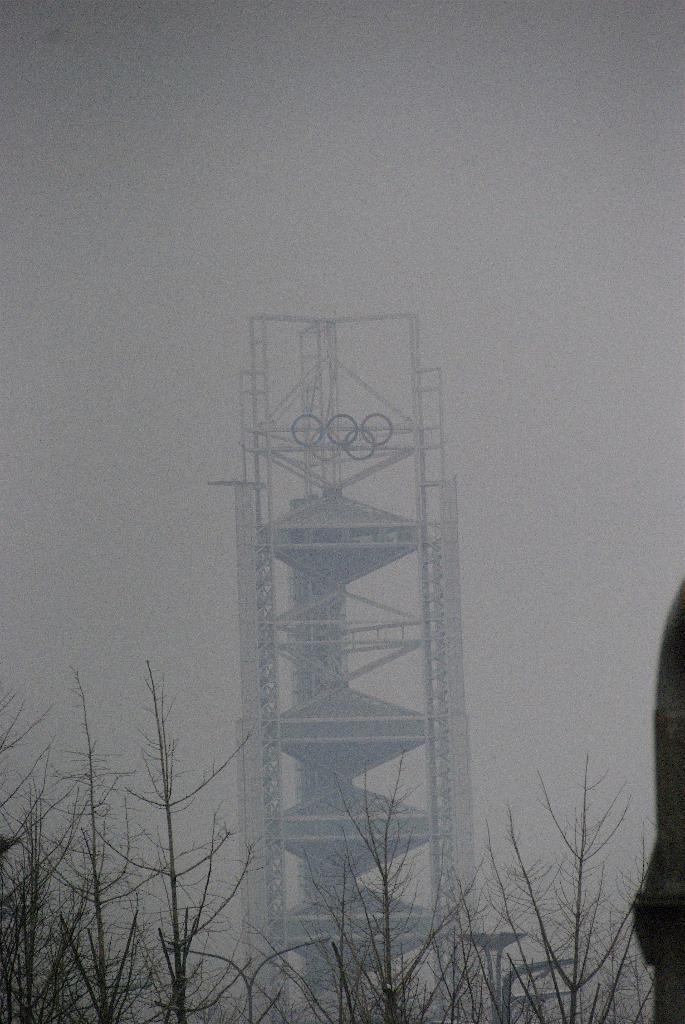Please provide a concise description of this image. There is a machine and it is covered with the fog, in the front there are few dry plants and a person is standing beside dry plants. 